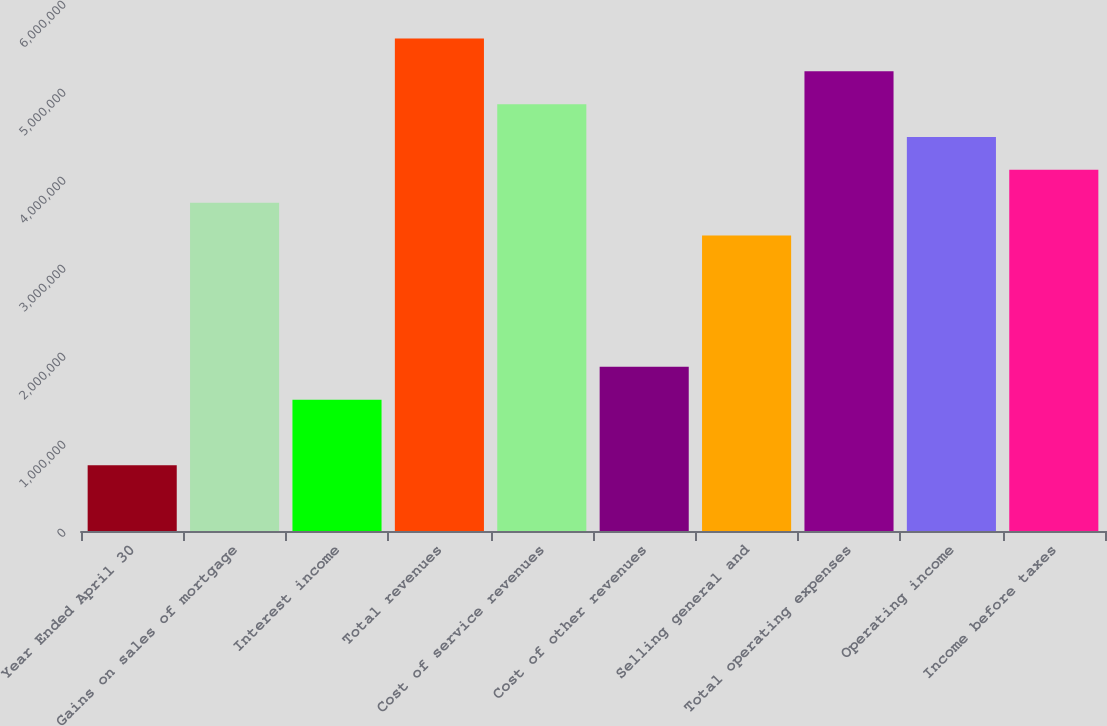Convert chart. <chart><loc_0><loc_0><loc_500><loc_500><bar_chart><fcel>Year Ended April 30<fcel>Gains on sales of mortgage<fcel>Interest income<fcel>Total revenues<fcel>Cost of service revenues<fcel>Cost of other revenues<fcel>Selling general and<fcel>Total operating expenses<fcel>Operating income<fcel>Income before taxes<nl><fcel>746226<fcel>3.73113e+06<fcel>1.49245e+06<fcel>5.59669e+06<fcel>4.85046e+06<fcel>1.86556e+06<fcel>3.35801e+06<fcel>5.22358e+06<fcel>4.47735e+06<fcel>4.10424e+06<nl></chart> 